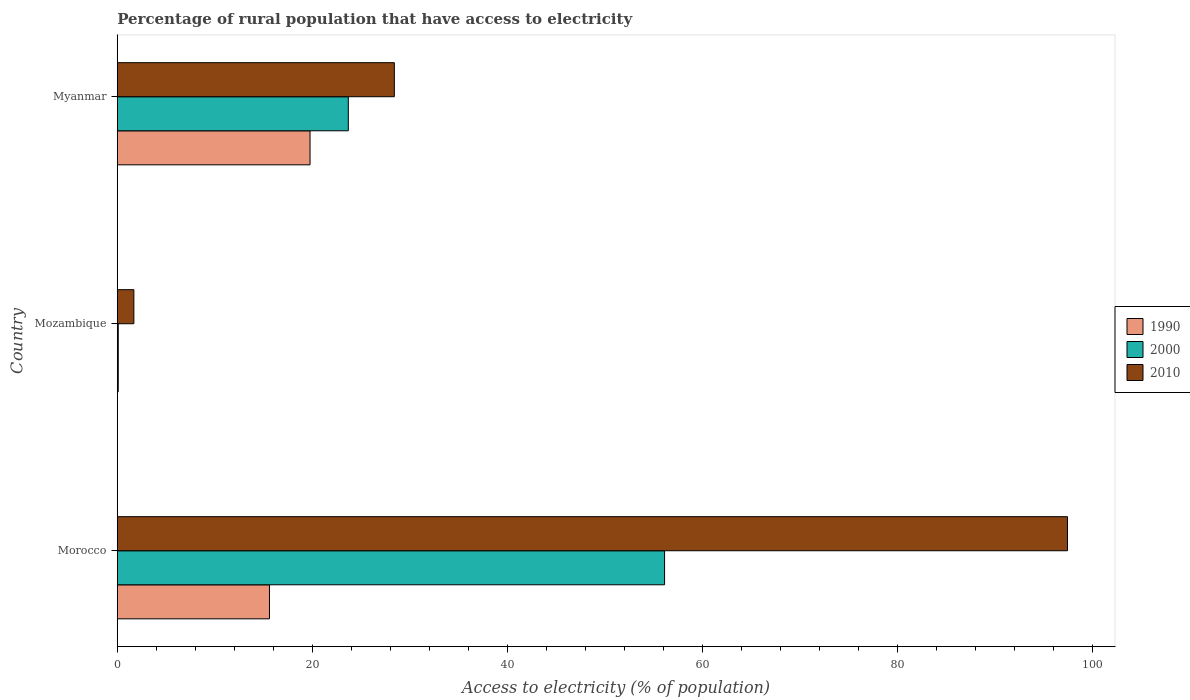How many groups of bars are there?
Your response must be concise. 3. Are the number of bars per tick equal to the number of legend labels?
Your answer should be very brief. Yes. How many bars are there on the 2nd tick from the bottom?
Your answer should be very brief. 3. What is the label of the 3rd group of bars from the top?
Give a very brief answer. Morocco. In how many cases, is the number of bars for a given country not equal to the number of legend labels?
Make the answer very short. 0. What is the percentage of rural population that have access to electricity in 2000 in Myanmar?
Your response must be concise. 23.68. Across all countries, what is the maximum percentage of rural population that have access to electricity in 2010?
Keep it short and to the point. 97.4. In which country was the percentage of rural population that have access to electricity in 2000 maximum?
Ensure brevity in your answer.  Morocco. In which country was the percentage of rural population that have access to electricity in 1990 minimum?
Give a very brief answer. Mozambique. What is the total percentage of rural population that have access to electricity in 2000 in the graph?
Ensure brevity in your answer.  79.88. What is the difference between the percentage of rural population that have access to electricity in 2010 in Morocco and that in Mozambique?
Your response must be concise. 95.7. What is the difference between the percentage of rural population that have access to electricity in 1990 in Myanmar and the percentage of rural population that have access to electricity in 2010 in Morocco?
Ensure brevity in your answer.  -77.64. What is the average percentage of rural population that have access to electricity in 2000 per country?
Ensure brevity in your answer.  26.63. What is the difference between the percentage of rural population that have access to electricity in 2010 and percentage of rural population that have access to electricity in 1990 in Mozambique?
Ensure brevity in your answer.  1.6. What is the ratio of the percentage of rural population that have access to electricity in 1990 in Morocco to that in Myanmar?
Your answer should be very brief. 0.79. Is the percentage of rural population that have access to electricity in 2010 in Morocco less than that in Mozambique?
Your answer should be very brief. No. Is the difference between the percentage of rural population that have access to electricity in 2010 in Mozambique and Myanmar greater than the difference between the percentage of rural population that have access to electricity in 1990 in Mozambique and Myanmar?
Your response must be concise. No. What is the difference between the highest and the second highest percentage of rural population that have access to electricity in 2010?
Provide a short and direct response. 69. What is the difference between the highest and the lowest percentage of rural population that have access to electricity in 1990?
Your response must be concise. 19.66. In how many countries, is the percentage of rural population that have access to electricity in 2010 greater than the average percentage of rural population that have access to electricity in 2010 taken over all countries?
Provide a short and direct response. 1. What does the 1st bar from the top in Myanmar represents?
Your answer should be compact. 2010. What does the 2nd bar from the bottom in Morocco represents?
Ensure brevity in your answer.  2000. Is it the case that in every country, the sum of the percentage of rural population that have access to electricity in 1990 and percentage of rural population that have access to electricity in 2000 is greater than the percentage of rural population that have access to electricity in 2010?
Ensure brevity in your answer.  No. How many bars are there?
Your answer should be very brief. 9. Are all the bars in the graph horizontal?
Offer a terse response. Yes. How many countries are there in the graph?
Your answer should be compact. 3. Are the values on the major ticks of X-axis written in scientific E-notation?
Provide a short and direct response. No. Does the graph contain any zero values?
Provide a short and direct response. No. Does the graph contain grids?
Offer a terse response. No. Where does the legend appear in the graph?
Your answer should be very brief. Center right. How are the legend labels stacked?
Offer a very short reply. Vertical. What is the title of the graph?
Your answer should be very brief. Percentage of rural population that have access to electricity. Does "1982" appear as one of the legend labels in the graph?
Offer a very short reply. No. What is the label or title of the X-axis?
Offer a very short reply. Access to electricity (% of population). What is the Access to electricity (% of population) of 1990 in Morocco?
Your response must be concise. 15.6. What is the Access to electricity (% of population) of 2000 in Morocco?
Provide a short and direct response. 56.1. What is the Access to electricity (% of population) in 2010 in Morocco?
Make the answer very short. 97.4. What is the Access to electricity (% of population) in 2000 in Mozambique?
Your response must be concise. 0.1. What is the Access to electricity (% of population) of 2010 in Mozambique?
Your response must be concise. 1.7. What is the Access to electricity (% of population) of 1990 in Myanmar?
Your answer should be very brief. 19.76. What is the Access to electricity (% of population) in 2000 in Myanmar?
Offer a very short reply. 23.68. What is the Access to electricity (% of population) of 2010 in Myanmar?
Your answer should be very brief. 28.4. Across all countries, what is the maximum Access to electricity (% of population) in 1990?
Keep it short and to the point. 19.76. Across all countries, what is the maximum Access to electricity (% of population) of 2000?
Provide a succinct answer. 56.1. Across all countries, what is the maximum Access to electricity (% of population) of 2010?
Provide a short and direct response. 97.4. Across all countries, what is the minimum Access to electricity (% of population) of 2000?
Your response must be concise. 0.1. Across all countries, what is the minimum Access to electricity (% of population) of 2010?
Offer a terse response. 1.7. What is the total Access to electricity (% of population) in 1990 in the graph?
Your response must be concise. 35.46. What is the total Access to electricity (% of population) of 2000 in the graph?
Provide a short and direct response. 79.88. What is the total Access to electricity (% of population) in 2010 in the graph?
Provide a short and direct response. 127.5. What is the difference between the Access to electricity (% of population) of 2000 in Morocco and that in Mozambique?
Provide a succinct answer. 56. What is the difference between the Access to electricity (% of population) in 2010 in Morocco and that in Mozambique?
Offer a terse response. 95.7. What is the difference between the Access to electricity (% of population) of 1990 in Morocco and that in Myanmar?
Make the answer very short. -4.16. What is the difference between the Access to electricity (% of population) in 2000 in Morocco and that in Myanmar?
Make the answer very short. 32.42. What is the difference between the Access to electricity (% of population) of 2010 in Morocco and that in Myanmar?
Provide a short and direct response. 69. What is the difference between the Access to electricity (% of population) in 1990 in Mozambique and that in Myanmar?
Make the answer very short. -19.66. What is the difference between the Access to electricity (% of population) of 2000 in Mozambique and that in Myanmar?
Ensure brevity in your answer.  -23.58. What is the difference between the Access to electricity (% of population) of 2010 in Mozambique and that in Myanmar?
Offer a terse response. -26.7. What is the difference between the Access to electricity (% of population) of 1990 in Morocco and the Access to electricity (% of population) of 2000 in Mozambique?
Make the answer very short. 15.5. What is the difference between the Access to electricity (% of population) in 2000 in Morocco and the Access to electricity (% of population) in 2010 in Mozambique?
Offer a terse response. 54.4. What is the difference between the Access to electricity (% of population) in 1990 in Morocco and the Access to electricity (% of population) in 2000 in Myanmar?
Your answer should be very brief. -8.08. What is the difference between the Access to electricity (% of population) in 2000 in Morocco and the Access to electricity (% of population) in 2010 in Myanmar?
Give a very brief answer. 27.7. What is the difference between the Access to electricity (% of population) of 1990 in Mozambique and the Access to electricity (% of population) of 2000 in Myanmar?
Give a very brief answer. -23.58. What is the difference between the Access to electricity (% of population) in 1990 in Mozambique and the Access to electricity (% of population) in 2010 in Myanmar?
Offer a very short reply. -28.3. What is the difference between the Access to electricity (% of population) of 2000 in Mozambique and the Access to electricity (% of population) of 2010 in Myanmar?
Provide a succinct answer. -28.3. What is the average Access to electricity (% of population) in 1990 per country?
Keep it short and to the point. 11.82. What is the average Access to electricity (% of population) of 2000 per country?
Keep it short and to the point. 26.63. What is the average Access to electricity (% of population) in 2010 per country?
Provide a succinct answer. 42.5. What is the difference between the Access to electricity (% of population) in 1990 and Access to electricity (% of population) in 2000 in Morocco?
Provide a succinct answer. -40.5. What is the difference between the Access to electricity (% of population) in 1990 and Access to electricity (% of population) in 2010 in Morocco?
Provide a short and direct response. -81.8. What is the difference between the Access to electricity (% of population) in 2000 and Access to electricity (% of population) in 2010 in Morocco?
Keep it short and to the point. -41.3. What is the difference between the Access to electricity (% of population) in 1990 and Access to electricity (% of population) in 2000 in Mozambique?
Ensure brevity in your answer.  0. What is the difference between the Access to electricity (% of population) in 1990 and Access to electricity (% of population) in 2010 in Mozambique?
Offer a very short reply. -1.6. What is the difference between the Access to electricity (% of population) in 2000 and Access to electricity (% of population) in 2010 in Mozambique?
Your answer should be very brief. -1.6. What is the difference between the Access to electricity (% of population) in 1990 and Access to electricity (% of population) in 2000 in Myanmar?
Your answer should be compact. -3.92. What is the difference between the Access to electricity (% of population) in 1990 and Access to electricity (% of population) in 2010 in Myanmar?
Ensure brevity in your answer.  -8.64. What is the difference between the Access to electricity (% of population) in 2000 and Access to electricity (% of population) in 2010 in Myanmar?
Provide a succinct answer. -4.72. What is the ratio of the Access to electricity (% of population) in 1990 in Morocco to that in Mozambique?
Provide a short and direct response. 156. What is the ratio of the Access to electricity (% of population) in 2000 in Morocco to that in Mozambique?
Give a very brief answer. 561.01. What is the ratio of the Access to electricity (% of population) in 2010 in Morocco to that in Mozambique?
Provide a short and direct response. 57.29. What is the ratio of the Access to electricity (% of population) of 1990 in Morocco to that in Myanmar?
Offer a very short reply. 0.79. What is the ratio of the Access to electricity (% of population) in 2000 in Morocco to that in Myanmar?
Provide a succinct answer. 2.37. What is the ratio of the Access to electricity (% of population) of 2010 in Morocco to that in Myanmar?
Make the answer very short. 3.43. What is the ratio of the Access to electricity (% of population) of 1990 in Mozambique to that in Myanmar?
Keep it short and to the point. 0.01. What is the ratio of the Access to electricity (% of population) of 2000 in Mozambique to that in Myanmar?
Keep it short and to the point. 0. What is the ratio of the Access to electricity (% of population) of 2010 in Mozambique to that in Myanmar?
Give a very brief answer. 0.06. What is the difference between the highest and the second highest Access to electricity (% of population) of 1990?
Give a very brief answer. 4.16. What is the difference between the highest and the second highest Access to electricity (% of population) of 2000?
Offer a terse response. 32.42. What is the difference between the highest and the lowest Access to electricity (% of population) in 1990?
Your answer should be very brief. 19.66. What is the difference between the highest and the lowest Access to electricity (% of population) in 2000?
Give a very brief answer. 56. What is the difference between the highest and the lowest Access to electricity (% of population) of 2010?
Provide a short and direct response. 95.7. 